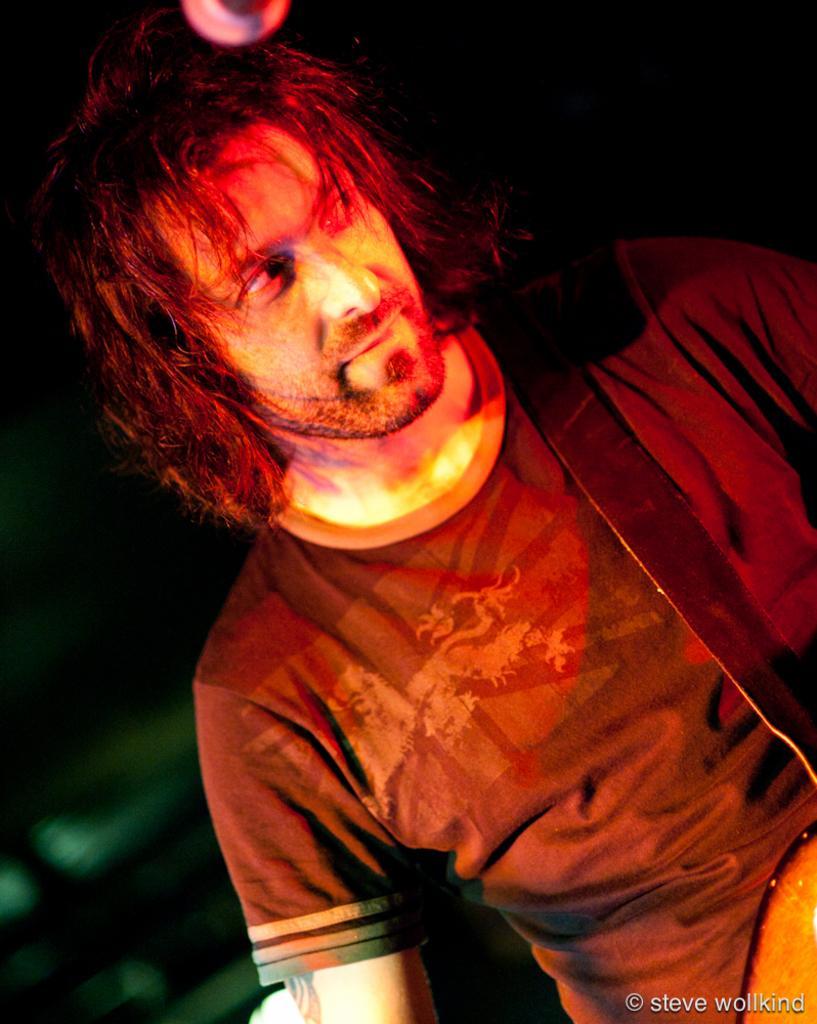How would you summarize this image in a sentence or two? This picture shows a man standing and holding a guitar and we see a microphone. 